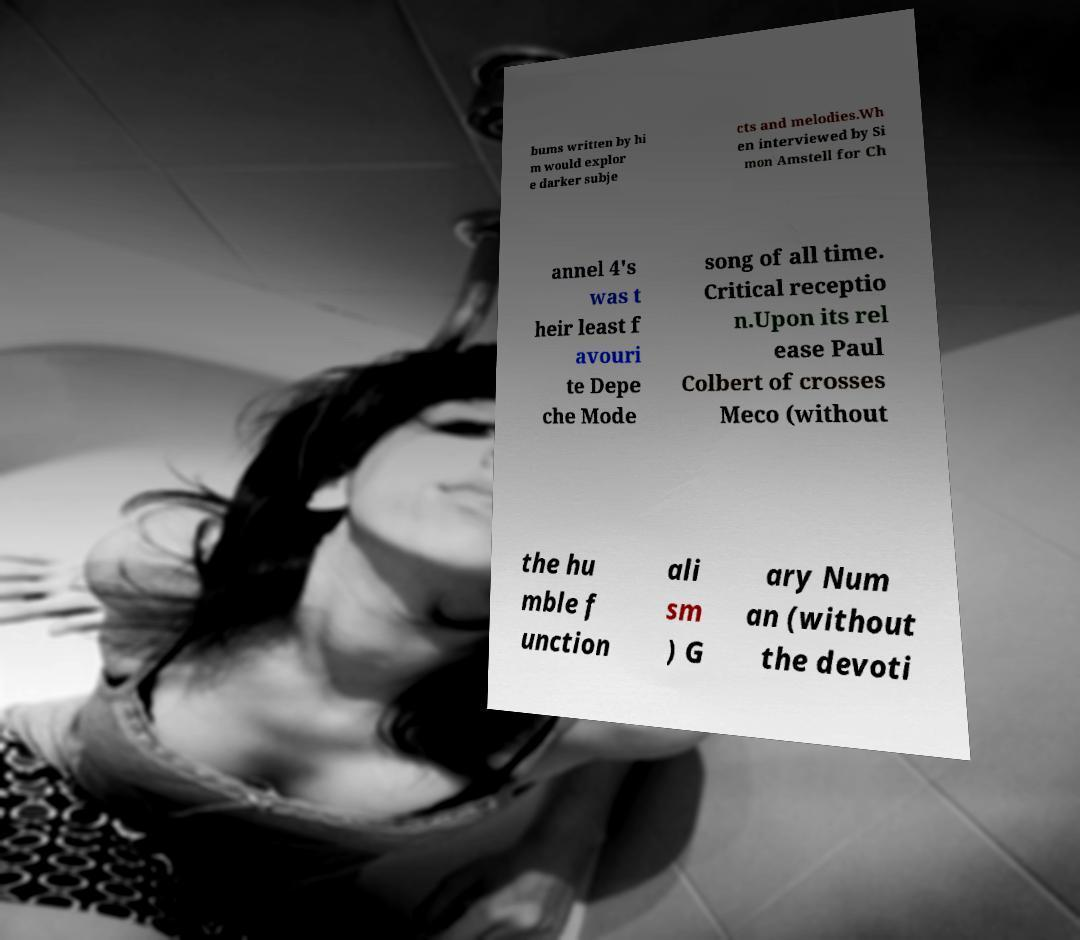Please read and relay the text visible in this image. What does it say? bums written by hi m would explor e darker subje cts and melodies.Wh en interviewed by Si mon Amstell for Ch annel 4's was t heir least f avouri te Depe che Mode song of all time. Critical receptio n.Upon its rel ease Paul Colbert of crosses Meco (without the hu mble f unction ali sm ) G ary Num an (without the devoti 